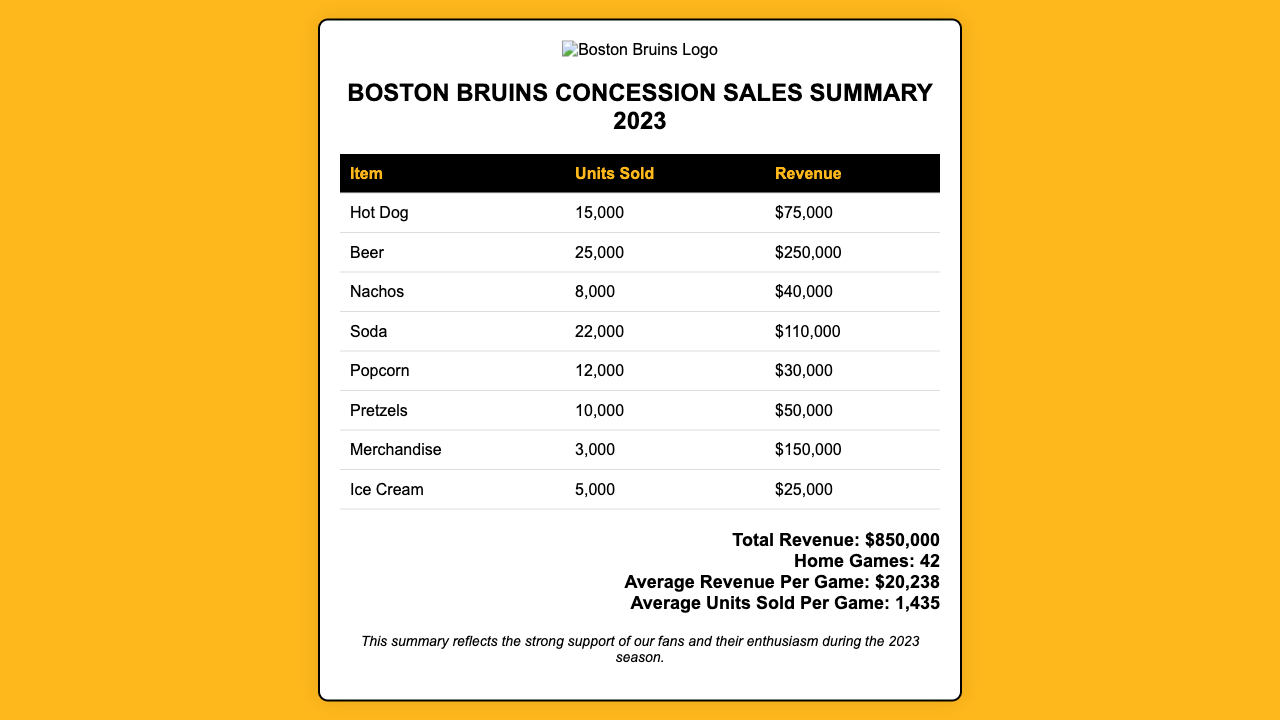what is the total revenue? The total revenue is presented at the bottom of the document, summarizing all sales, which totals $850,000.
Answer: $850,000 how many home games were played? The document states that there were 42 home games during the 2023 season.
Answer: 42 which item generated the highest revenue? The revenue for each item is listed, and the item with the highest revenue is Beer, generating $250,000.
Answer: Beer how many units of Nachos were sold? The document specifies that 8,000 units of Nachos were sold during the season.
Answer: 8,000 what is the average revenue per game? The average revenue per game is calculated and presented as $20,238 in the document.
Answer: $20,238 what is the total number of items sold across all categories? To find the total units sold, one would sum the units sold of all items, which totals 60,000.
Answer: 60,000 how much revenue did Merchandise generate? The document indicates that the Merchandise category generated $150,000 in revenue.
Answer: $150,000 how many units of Ice Cream were sold? According to the document, 5,000 units of Ice Cream were sold during the games.
Answer: 5,000 